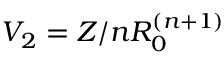<formula> <loc_0><loc_0><loc_500><loc_500>V _ { 2 } = Z / n R _ { 0 } ^ { ( n + 1 ) }</formula> 